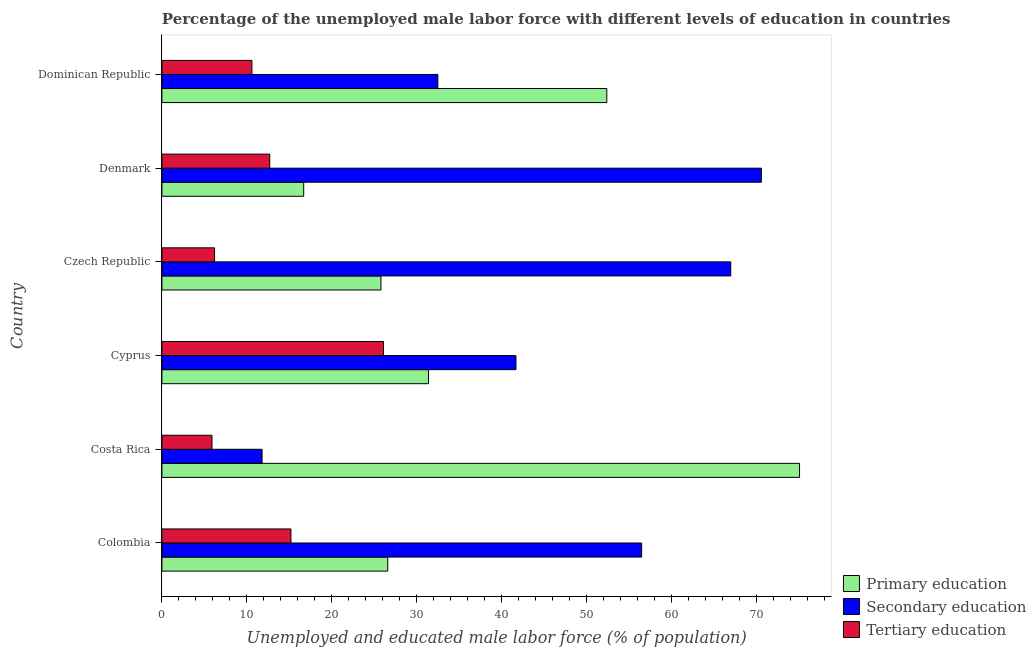How many different coloured bars are there?
Offer a terse response. 3. How many groups of bars are there?
Offer a very short reply. 6. What is the percentage of male labor force who received tertiary education in Colombia?
Keep it short and to the point. 15.2. Across all countries, what is the maximum percentage of male labor force who received primary education?
Your response must be concise. 75.1. Across all countries, what is the minimum percentage of male labor force who received secondary education?
Ensure brevity in your answer.  11.8. In which country was the percentage of male labor force who received primary education maximum?
Your response must be concise. Costa Rica. What is the total percentage of male labor force who received tertiary education in the graph?
Ensure brevity in your answer.  76.7. What is the difference between the percentage of male labor force who received primary education in Cyprus and that in Dominican Republic?
Your response must be concise. -21. What is the difference between the percentage of male labor force who received tertiary education in Dominican Republic and the percentage of male labor force who received secondary education in Czech Republic?
Your answer should be very brief. -56.4. What is the average percentage of male labor force who received secondary education per country?
Provide a short and direct response. 46.68. What is the difference between the percentage of male labor force who received secondary education and percentage of male labor force who received primary education in Denmark?
Keep it short and to the point. 53.9. What is the ratio of the percentage of male labor force who received secondary education in Cyprus to that in Czech Republic?
Give a very brief answer. 0.62. What is the difference between the highest and the second highest percentage of male labor force who received primary education?
Your answer should be compact. 22.7. What is the difference between the highest and the lowest percentage of male labor force who received primary education?
Make the answer very short. 58.4. In how many countries, is the percentage of male labor force who received secondary education greater than the average percentage of male labor force who received secondary education taken over all countries?
Offer a very short reply. 3. What does the 1st bar from the bottom in Costa Rica represents?
Give a very brief answer. Primary education. Is it the case that in every country, the sum of the percentage of male labor force who received primary education and percentage of male labor force who received secondary education is greater than the percentage of male labor force who received tertiary education?
Your response must be concise. Yes. Are all the bars in the graph horizontal?
Offer a very short reply. Yes. How many countries are there in the graph?
Provide a short and direct response. 6. What is the difference between two consecutive major ticks on the X-axis?
Your response must be concise. 10. Are the values on the major ticks of X-axis written in scientific E-notation?
Provide a short and direct response. No. How many legend labels are there?
Your answer should be very brief. 3. What is the title of the graph?
Make the answer very short. Percentage of the unemployed male labor force with different levels of education in countries. Does "Travel services" appear as one of the legend labels in the graph?
Offer a very short reply. No. What is the label or title of the X-axis?
Your answer should be compact. Unemployed and educated male labor force (% of population). What is the Unemployed and educated male labor force (% of population) in Primary education in Colombia?
Your response must be concise. 26.6. What is the Unemployed and educated male labor force (% of population) in Secondary education in Colombia?
Your response must be concise. 56.5. What is the Unemployed and educated male labor force (% of population) in Tertiary education in Colombia?
Provide a short and direct response. 15.2. What is the Unemployed and educated male labor force (% of population) in Primary education in Costa Rica?
Provide a succinct answer. 75.1. What is the Unemployed and educated male labor force (% of population) in Secondary education in Costa Rica?
Your answer should be very brief. 11.8. What is the Unemployed and educated male labor force (% of population) of Tertiary education in Costa Rica?
Provide a succinct answer. 5.9. What is the Unemployed and educated male labor force (% of population) of Primary education in Cyprus?
Offer a terse response. 31.4. What is the Unemployed and educated male labor force (% of population) of Secondary education in Cyprus?
Offer a terse response. 41.7. What is the Unemployed and educated male labor force (% of population) of Tertiary education in Cyprus?
Ensure brevity in your answer.  26.1. What is the Unemployed and educated male labor force (% of population) of Primary education in Czech Republic?
Offer a terse response. 25.8. What is the Unemployed and educated male labor force (% of population) in Secondary education in Czech Republic?
Offer a very short reply. 67. What is the Unemployed and educated male labor force (% of population) of Tertiary education in Czech Republic?
Your response must be concise. 6.2. What is the Unemployed and educated male labor force (% of population) of Primary education in Denmark?
Make the answer very short. 16.7. What is the Unemployed and educated male labor force (% of population) of Secondary education in Denmark?
Your answer should be very brief. 70.6. What is the Unemployed and educated male labor force (% of population) of Tertiary education in Denmark?
Offer a terse response. 12.7. What is the Unemployed and educated male labor force (% of population) of Primary education in Dominican Republic?
Provide a succinct answer. 52.4. What is the Unemployed and educated male labor force (% of population) in Secondary education in Dominican Republic?
Give a very brief answer. 32.5. What is the Unemployed and educated male labor force (% of population) in Tertiary education in Dominican Republic?
Make the answer very short. 10.6. Across all countries, what is the maximum Unemployed and educated male labor force (% of population) in Primary education?
Give a very brief answer. 75.1. Across all countries, what is the maximum Unemployed and educated male labor force (% of population) in Secondary education?
Your answer should be compact. 70.6. Across all countries, what is the maximum Unemployed and educated male labor force (% of population) of Tertiary education?
Provide a succinct answer. 26.1. Across all countries, what is the minimum Unemployed and educated male labor force (% of population) of Primary education?
Make the answer very short. 16.7. Across all countries, what is the minimum Unemployed and educated male labor force (% of population) of Secondary education?
Make the answer very short. 11.8. Across all countries, what is the minimum Unemployed and educated male labor force (% of population) in Tertiary education?
Give a very brief answer. 5.9. What is the total Unemployed and educated male labor force (% of population) in Primary education in the graph?
Your response must be concise. 228. What is the total Unemployed and educated male labor force (% of population) of Secondary education in the graph?
Offer a terse response. 280.1. What is the total Unemployed and educated male labor force (% of population) of Tertiary education in the graph?
Your response must be concise. 76.7. What is the difference between the Unemployed and educated male labor force (% of population) in Primary education in Colombia and that in Costa Rica?
Your answer should be compact. -48.5. What is the difference between the Unemployed and educated male labor force (% of population) of Secondary education in Colombia and that in Costa Rica?
Your answer should be very brief. 44.7. What is the difference between the Unemployed and educated male labor force (% of population) of Primary education in Colombia and that in Cyprus?
Make the answer very short. -4.8. What is the difference between the Unemployed and educated male labor force (% of population) in Secondary education in Colombia and that in Cyprus?
Your answer should be compact. 14.8. What is the difference between the Unemployed and educated male labor force (% of population) in Tertiary education in Colombia and that in Cyprus?
Make the answer very short. -10.9. What is the difference between the Unemployed and educated male labor force (% of population) of Primary education in Colombia and that in Czech Republic?
Provide a succinct answer. 0.8. What is the difference between the Unemployed and educated male labor force (% of population) of Secondary education in Colombia and that in Czech Republic?
Your answer should be very brief. -10.5. What is the difference between the Unemployed and educated male labor force (% of population) in Primary education in Colombia and that in Denmark?
Make the answer very short. 9.9. What is the difference between the Unemployed and educated male labor force (% of population) in Secondary education in Colombia and that in Denmark?
Offer a very short reply. -14.1. What is the difference between the Unemployed and educated male labor force (% of population) of Tertiary education in Colombia and that in Denmark?
Offer a very short reply. 2.5. What is the difference between the Unemployed and educated male labor force (% of population) of Primary education in Colombia and that in Dominican Republic?
Ensure brevity in your answer.  -25.8. What is the difference between the Unemployed and educated male labor force (% of population) of Secondary education in Colombia and that in Dominican Republic?
Offer a terse response. 24. What is the difference between the Unemployed and educated male labor force (% of population) in Tertiary education in Colombia and that in Dominican Republic?
Your answer should be compact. 4.6. What is the difference between the Unemployed and educated male labor force (% of population) of Primary education in Costa Rica and that in Cyprus?
Your response must be concise. 43.7. What is the difference between the Unemployed and educated male labor force (% of population) in Secondary education in Costa Rica and that in Cyprus?
Your answer should be compact. -29.9. What is the difference between the Unemployed and educated male labor force (% of population) of Tertiary education in Costa Rica and that in Cyprus?
Make the answer very short. -20.2. What is the difference between the Unemployed and educated male labor force (% of population) in Primary education in Costa Rica and that in Czech Republic?
Keep it short and to the point. 49.3. What is the difference between the Unemployed and educated male labor force (% of population) in Secondary education in Costa Rica and that in Czech Republic?
Your answer should be compact. -55.2. What is the difference between the Unemployed and educated male labor force (% of population) of Primary education in Costa Rica and that in Denmark?
Ensure brevity in your answer.  58.4. What is the difference between the Unemployed and educated male labor force (% of population) of Secondary education in Costa Rica and that in Denmark?
Make the answer very short. -58.8. What is the difference between the Unemployed and educated male labor force (% of population) of Primary education in Costa Rica and that in Dominican Republic?
Keep it short and to the point. 22.7. What is the difference between the Unemployed and educated male labor force (% of population) in Secondary education in Costa Rica and that in Dominican Republic?
Offer a very short reply. -20.7. What is the difference between the Unemployed and educated male labor force (% of population) in Tertiary education in Costa Rica and that in Dominican Republic?
Make the answer very short. -4.7. What is the difference between the Unemployed and educated male labor force (% of population) of Primary education in Cyprus and that in Czech Republic?
Your response must be concise. 5.6. What is the difference between the Unemployed and educated male labor force (% of population) of Secondary education in Cyprus and that in Czech Republic?
Offer a very short reply. -25.3. What is the difference between the Unemployed and educated male labor force (% of population) in Tertiary education in Cyprus and that in Czech Republic?
Your answer should be very brief. 19.9. What is the difference between the Unemployed and educated male labor force (% of population) of Secondary education in Cyprus and that in Denmark?
Offer a terse response. -28.9. What is the difference between the Unemployed and educated male labor force (% of population) of Tertiary education in Cyprus and that in Denmark?
Offer a terse response. 13.4. What is the difference between the Unemployed and educated male labor force (% of population) in Tertiary education in Cyprus and that in Dominican Republic?
Keep it short and to the point. 15.5. What is the difference between the Unemployed and educated male labor force (% of population) in Tertiary education in Czech Republic and that in Denmark?
Your response must be concise. -6.5. What is the difference between the Unemployed and educated male labor force (% of population) of Primary education in Czech Republic and that in Dominican Republic?
Your answer should be compact. -26.6. What is the difference between the Unemployed and educated male labor force (% of population) of Secondary education in Czech Republic and that in Dominican Republic?
Ensure brevity in your answer.  34.5. What is the difference between the Unemployed and educated male labor force (% of population) of Tertiary education in Czech Republic and that in Dominican Republic?
Give a very brief answer. -4.4. What is the difference between the Unemployed and educated male labor force (% of population) in Primary education in Denmark and that in Dominican Republic?
Provide a succinct answer. -35.7. What is the difference between the Unemployed and educated male labor force (% of population) in Secondary education in Denmark and that in Dominican Republic?
Your answer should be compact. 38.1. What is the difference between the Unemployed and educated male labor force (% of population) of Primary education in Colombia and the Unemployed and educated male labor force (% of population) of Tertiary education in Costa Rica?
Give a very brief answer. 20.7. What is the difference between the Unemployed and educated male labor force (% of population) of Secondary education in Colombia and the Unemployed and educated male labor force (% of population) of Tertiary education in Costa Rica?
Your answer should be very brief. 50.6. What is the difference between the Unemployed and educated male labor force (% of population) in Primary education in Colombia and the Unemployed and educated male labor force (% of population) in Secondary education in Cyprus?
Keep it short and to the point. -15.1. What is the difference between the Unemployed and educated male labor force (% of population) of Secondary education in Colombia and the Unemployed and educated male labor force (% of population) of Tertiary education in Cyprus?
Offer a terse response. 30.4. What is the difference between the Unemployed and educated male labor force (% of population) of Primary education in Colombia and the Unemployed and educated male labor force (% of population) of Secondary education in Czech Republic?
Give a very brief answer. -40.4. What is the difference between the Unemployed and educated male labor force (% of population) of Primary education in Colombia and the Unemployed and educated male labor force (% of population) of Tertiary education in Czech Republic?
Give a very brief answer. 20.4. What is the difference between the Unemployed and educated male labor force (% of population) of Secondary education in Colombia and the Unemployed and educated male labor force (% of population) of Tertiary education in Czech Republic?
Your answer should be very brief. 50.3. What is the difference between the Unemployed and educated male labor force (% of population) of Primary education in Colombia and the Unemployed and educated male labor force (% of population) of Secondary education in Denmark?
Ensure brevity in your answer.  -44. What is the difference between the Unemployed and educated male labor force (% of population) of Secondary education in Colombia and the Unemployed and educated male labor force (% of population) of Tertiary education in Denmark?
Your answer should be very brief. 43.8. What is the difference between the Unemployed and educated male labor force (% of population) in Secondary education in Colombia and the Unemployed and educated male labor force (% of population) in Tertiary education in Dominican Republic?
Offer a terse response. 45.9. What is the difference between the Unemployed and educated male labor force (% of population) of Primary education in Costa Rica and the Unemployed and educated male labor force (% of population) of Secondary education in Cyprus?
Ensure brevity in your answer.  33.4. What is the difference between the Unemployed and educated male labor force (% of population) of Primary education in Costa Rica and the Unemployed and educated male labor force (% of population) of Tertiary education in Cyprus?
Provide a succinct answer. 49. What is the difference between the Unemployed and educated male labor force (% of population) of Secondary education in Costa Rica and the Unemployed and educated male labor force (% of population) of Tertiary education in Cyprus?
Your response must be concise. -14.3. What is the difference between the Unemployed and educated male labor force (% of population) in Primary education in Costa Rica and the Unemployed and educated male labor force (% of population) in Secondary education in Czech Republic?
Make the answer very short. 8.1. What is the difference between the Unemployed and educated male labor force (% of population) of Primary education in Costa Rica and the Unemployed and educated male labor force (% of population) of Tertiary education in Czech Republic?
Make the answer very short. 68.9. What is the difference between the Unemployed and educated male labor force (% of population) of Primary education in Costa Rica and the Unemployed and educated male labor force (% of population) of Tertiary education in Denmark?
Provide a succinct answer. 62.4. What is the difference between the Unemployed and educated male labor force (% of population) in Secondary education in Costa Rica and the Unemployed and educated male labor force (% of population) in Tertiary education in Denmark?
Your answer should be compact. -0.9. What is the difference between the Unemployed and educated male labor force (% of population) in Primary education in Costa Rica and the Unemployed and educated male labor force (% of population) in Secondary education in Dominican Republic?
Make the answer very short. 42.6. What is the difference between the Unemployed and educated male labor force (% of population) of Primary education in Costa Rica and the Unemployed and educated male labor force (% of population) of Tertiary education in Dominican Republic?
Provide a short and direct response. 64.5. What is the difference between the Unemployed and educated male labor force (% of population) in Secondary education in Costa Rica and the Unemployed and educated male labor force (% of population) in Tertiary education in Dominican Republic?
Provide a short and direct response. 1.2. What is the difference between the Unemployed and educated male labor force (% of population) of Primary education in Cyprus and the Unemployed and educated male labor force (% of population) of Secondary education in Czech Republic?
Ensure brevity in your answer.  -35.6. What is the difference between the Unemployed and educated male labor force (% of population) of Primary education in Cyprus and the Unemployed and educated male labor force (% of population) of Tertiary education in Czech Republic?
Offer a very short reply. 25.2. What is the difference between the Unemployed and educated male labor force (% of population) in Secondary education in Cyprus and the Unemployed and educated male labor force (% of population) in Tertiary education in Czech Republic?
Your response must be concise. 35.5. What is the difference between the Unemployed and educated male labor force (% of population) in Primary education in Cyprus and the Unemployed and educated male labor force (% of population) in Secondary education in Denmark?
Your answer should be very brief. -39.2. What is the difference between the Unemployed and educated male labor force (% of population) in Primary education in Cyprus and the Unemployed and educated male labor force (% of population) in Tertiary education in Denmark?
Provide a short and direct response. 18.7. What is the difference between the Unemployed and educated male labor force (% of population) of Primary education in Cyprus and the Unemployed and educated male labor force (% of population) of Secondary education in Dominican Republic?
Offer a terse response. -1.1. What is the difference between the Unemployed and educated male labor force (% of population) of Primary education in Cyprus and the Unemployed and educated male labor force (% of population) of Tertiary education in Dominican Republic?
Provide a succinct answer. 20.8. What is the difference between the Unemployed and educated male labor force (% of population) in Secondary education in Cyprus and the Unemployed and educated male labor force (% of population) in Tertiary education in Dominican Republic?
Your answer should be compact. 31.1. What is the difference between the Unemployed and educated male labor force (% of population) of Primary education in Czech Republic and the Unemployed and educated male labor force (% of population) of Secondary education in Denmark?
Keep it short and to the point. -44.8. What is the difference between the Unemployed and educated male labor force (% of population) of Secondary education in Czech Republic and the Unemployed and educated male labor force (% of population) of Tertiary education in Denmark?
Keep it short and to the point. 54.3. What is the difference between the Unemployed and educated male labor force (% of population) of Primary education in Czech Republic and the Unemployed and educated male labor force (% of population) of Secondary education in Dominican Republic?
Keep it short and to the point. -6.7. What is the difference between the Unemployed and educated male labor force (% of population) of Secondary education in Czech Republic and the Unemployed and educated male labor force (% of population) of Tertiary education in Dominican Republic?
Your answer should be very brief. 56.4. What is the difference between the Unemployed and educated male labor force (% of population) in Primary education in Denmark and the Unemployed and educated male labor force (% of population) in Secondary education in Dominican Republic?
Provide a succinct answer. -15.8. What is the difference between the Unemployed and educated male labor force (% of population) in Primary education in Denmark and the Unemployed and educated male labor force (% of population) in Tertiary education in Dominican Republic?
Provide a short and direct response. 6.1. What is the difference between the Unemployed and educated male labor force (% of population) in Secondary education in Denmark and the Unemployed and educated male labor force (% of population) in Tertiary education in Dominican Republic?
Offer a terse response. 60. What is the average Unemployed and educated male labor force (% of population) of Primary education per country?
Offer a terse response. 38. What is the average Unemployed and educated male labor force (% of population) of Secondary education per country?
Your answer should be compact. 46.68. What is the average Unemployed and educated male labor force (% of population) in Tertiary education per country?
Keep it short and to the point. 12.78. What is the difference between the Unemployed and educated male labor force (% of population) of Primary education and Unemployed and educated male labor force (% of population) of Secondary education in Colombia?
Your answer should be very brief. -29.9. What is the difference between the Unemployed and educated male labor force (% of population) of Secondary education and Unemployed and educated male labor force (% of population) of Tertiary education in Colombia?
Keep it short and to the point. 41.3. What is the difference between the Unemployed and educated male labor force (% of population) in Primary education and Unemployed and educated male labor force (% of population) in Secondary education in Costa Rica?
Your answer should be very brief. 63.3. What is the difference between the Unemployed and educated male labor force (% of population) in Primary education and Unemployed and educated male labor force (% of population) in Tertiary education in Costa Rica?
Your response must be concise. 69.2. What is the difference between the Unemployed and educated male labor force (% of population) of Primary education and Unemployed and educated male labor force (% of population) of Tertiary education in Cyprus?
Give a very brief answer. 5.3. What is the difference between the Unemployed and educated male labor force (% of population) of Primary education and Unemployed and educated male labor force (% of population) of Secondary education in Czech Republic?
Provide a short and direct response. -41.2. What is the difference between the Unemployed and educated male labor force (% of population) of Primary education and Unemployed and educated male labor force (% of population) of Tertiary education in Czech Republic?
Provide a short and direct response. 19.6. What is the difference between the Unemployed and educated male labor force (% of population) in Secondary education and Unemployed and educated male labor force (% of population) in Tertiary education in Czech Republic?
Make the answer very short. 60.8. What is the difference between the Unemployed and educated male labor force (% of population) of Primary education and Unemployed and educated male labor force (% of population) of Secondary education in Denmark?
Your response must be concise. -53.9. What is the difference between the Unemployed and educated male labor force (% of population) of Primary education and Unemployed and educated male labor force (% of population) of Tertiary education in Denmark?
Keep it short and to the point. 4. What is the difference between the Unemployed and educated male labor force (% of population) of Secondary education and Unemployed and educated male labor force (% of population) of Tertiary education in Denmark?
Offer a terse response. 57.9. What is the difference between the Unemployed and educated male labor force (% of population) of Primary education and Unemployed and educated male labor force (% of population) of Tertiary education in Dominican Republic?
Make the answer very short. 41.8. What is the difference between the Unemployed and educated male labor force (% of population) in Secondary education and Unemployed and educated male labor force (% of population) in Tertiary education in Dominican Republic?
Ensure brevity in your answer.  21.9. What is the ratio of the Unemployed and educated male labor force (% of population) of Primary education in Colombia to that in Costa Rica?
Keep it short and to the point. 0.35. What is the ratio of the Unemployed and educated male labor force (% of population) of Secondary education in Colombia to that in Costa Rica?
Provide a succinct answer. 4.79. What is the ratio of the Unemployed and educated male labor force (% of population) of Tertiary education in Colombia to that in Costa Rica?
Give a very brief answer. 2.58. What is the ratio of the Unemployed and educated male labor force (% of population) of Primary education in Colombia to that in Cyprus?
Your answer should be very brief. 0.85. What is the ratio of the Unemployed and educated male labor force (% of population) of Secondary education in Colombia to that in Cyprus?
Your answer should be very brief. 1.35. What is the ratio of the Unemployed and educated male labor force (% of population) in Tertiary education in Colombia to that in Cyprus?
Provide a short and direct response. 0.58. What is the ratio of the Unemployed and educated male labor force (% of population) in Primary education in Colombia to that in Czech Republic?
Make the answer very short. 1.03. What is the ratio of the Unemployed and educated male labor force (% of population) in Secondary education in Colombia to that in Czech Republic?
Make the answer very short. 0.84. What is the ratio of the Unemployed and educated male labor force (% of population) in Tertiary education in Colombia to that in Czech Republic?
Provide a short and direct response. 2.45. What is the ratio of the Unemployed and educated male labor force (% of population) of Primary education in Colombia to that in Denmark?
Make the answer very short. 1.59. What is the ratio of the Unemployed and educated male labor force (% of population) in Secondary education in Colombia to that in Denmark?
Offer a very short reply. 0.8. What is the ratio of the Unemployed and educated male labor force (% of population) in Tertiary education in Colombia to that in Denmark?
Keep it short and to the point. 1.2. What is the ratio of the Unemployed and educated male labor force (% of population) of Primary education in Colombia to that in Dominican Republic?
Ensure brevity in your answer.  0.51. What is the ratio of the Unemployed and educated male labor force (% of population) of Secondary education in Colombia to that in Dominican Republic?
Provide a succinct answer. 1.74. What is the ratio of the Unemployed and educated male labor force (% of population) of Tertiary education in Colombia to that in Dominican Republic?
Give a very brief answer. 1.43. What is the ratio of the Unemployed and educated male labor force (% of population) of Primary education in Costa Rica to that in Cyprus?
Your answer should be compact. 2.39. What is the ratio of the Unemployed and educated male labor force (% of population) of Secondary education in Costa Rica to that in Cyprus?
Your response must be concise. 0.28. What is the ratio of the Unemployed and educated male labor force (% of population) of Tertiary education in Costa Rica to that in Cyprus?
Offer a very short reply. 0.23. What is the ratio of the Unemployed and educated male labor force (% of population) of Primary education in Costa Rica to that in Czech Republic?
Provide a succinct answer. 2.91. What is the ratio of the Unemployed and educated male labor force (% of population) in Secondary education in Costa Rica to that in Czech Republic?
Offer a terse response. 0.18. What is the ratio of the Unemployed and educated male labor force (% of population) of Tertiary education in Costa Rica to that in Czech Republic?
Offer a terse response. 0.95. What is the ratio of the Unemployed and educated male labor force (% of population) in Primary education in Costa Rica to that in Denmark?
Offer a terse response. 4.5. What is the ratio of the Unemployed and educated male labor force (% of population) in Secondary education in Costa Rica to that in Denmark?
Your answer should be compact. 0.17. What is the ratio of the Unemployed and educated male labor force (% of population) of Tertiary education in Costa Rica to that in Denmark?
Give a very brief answer. 0.46. What is the ratio of the Unemployed and educated male labor force (% of population) in Primary education in Costa Rica to that in Dominican Republic?
Keep it short and to the point. 1.43. What is the ratio of the Unemployed and educated male labor force (% of population) of Secondary education in Costa Rica to that in Dominican Republic?
Provide a short and direct response. 0.36. What is the ratio of the Unemployed and educated male labor force (% of population) in Tertiary education in Costa Rica to that in Dominican Republic?
Keep it short and to the point. 0.56. What is the ratio of the Unemployed and educated male labor force (% of population) of Primary education in Cyprus to that in Czech Republic?
Your answer should be compact. 1.22. What is the ratio of the Unemployed and educated male labor force (% of population) in Secondary education in Cyprus to that in Czech Republic?
Keep it short and to the point. 0.62. What is the ratio of the Unemployed and educated male labor force (% of population) in Tertiary education in Cyprus to that in Czech Republic?
Your answer should be very brief. 4.21. What is the ratio of the Unemployed and educated male labor force (% of population) of Primary education in Cyprus to that in Denmark?
Provide a short and direct response. 1.88. What is the ratio of the Unemployed and educated male labor force (% of population) in Secondary education in Cyprus to that in Denmark?
Your response must be concise. 0.59. What is the ratio of the Unemployed and educated male labor force (% of population) of Tertiary education in Cyprus to that in Denmark?
Ensure brevity in your answer.  2.06. What is the ratio of the Unemployed and educated male labor force (% of population) in Primary education in Cyprus to that in Dominican Republic?
Provide a short and direct response. 0.6. What is the ratio of the Unemployed and educated male labor force (% of population) in Secondary education in Cyprus to that in Dominican Republic?
Offer a very short reply. 1.28. What is the ratio of the Unemployed and educated male labor force (% of population) in Tertiary education in Cyprus to that in Dominican Republic?
Ensure brevity in your answer.  2.46. What is the ratio of the Unemployed and educated male labor force (% of population) in Primary education in Czech Republic to that in Denmark?
Provide a succinct answer. 1.54. What is the ratio of the Unemployed and educated male labor force (% of population) in Secondary education in Czech Republic to that in Denmark?
Your answer should be compact. 0.95. What is the ratio of the Unemployed and educated male labor force (% of population) of Tertiary education in Czech Republic to that in Denmark?
Your answer should be very brief. 0.49. What is the ratio of the Unemployed and educated male labor force (% of population) of Primary education in Czech Republic to that in Dominican Republic?
Ensure brevity in your answer.  0.49. What is the ratio of the Unemployed and educated male labor force (% of population) in Secondary education in Czech Republic to that in Dominican Republic?
Give a very brief answer. 2.06. What is the ratio of the Unemployed and educated male labor force (% of population) of Tertiary education in Czech Republic to that in Dominican Republic?
Provide a short and direct response. 0.58. What is the ratio of the Unemployed and educated male labor force (% of population) in Primary education in Denmark to that in Dominican Republic?
Keep it short and to the point. 0.32. What is the ratio of the Unemployed and educated male labor force (% of population) of Secondary education in Denmark to that in Dominican Republic?
Ensure brevity in your answer.  2.17. What is the ratio of the Unemployed and educated male labor force (% of population) of Tertiary education in Denmark to that in Dominican Republic?
Your answer should be compact. 1.2. What is the difference between the highest and the second highest Unemployed and educated male labor force (% of population) of Primary education?
Make the answer very short. 22.7. What is the difference between the highest and the second highest Unemployed and educated male labor force (% of population) of Secondary education?
Make the answer very short. 3.6. What is the difference between the highest and the second highest Unemployed and educated male labor force (% of population) in Tertiary education?
Provide a short and direct response. 10.9. What is the difference between the highest and the lowest Unemployed and educated male labor force (% of population) in Primary education?
Your answer should be very brief. 58.4. What is the difference between the highest and the lowest Unemployed and educated male labor force (% of population) in Secondary education?
Provide a short and direct response. 58.8. What is the difference between the highest and the lowest Unemployed and educated male labor force (% of population) in Tertiary education?
Provide a short and direct response. 20.2. 